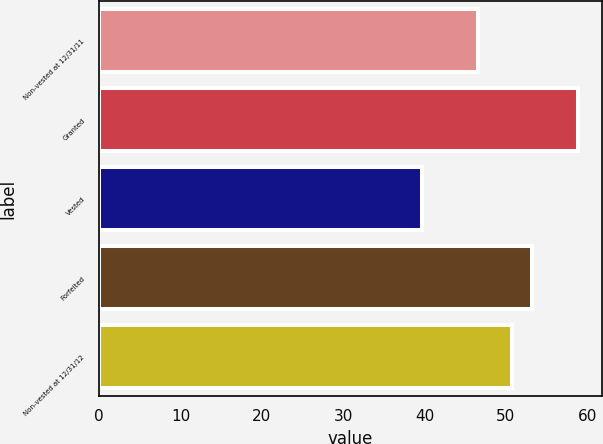<chart> <loc_0><loc_0><loc_500><loc_500><bar_chart><fcel>Non-vested at 12/31/11<fcel>Granted<fcel>Vested<fcel>Forfeited<fcel>Non-vested at 12/31/12<nl><fcel>46.6<fcel>58.84<fcel>39.67<fcel>53.18<fcel>50.78<nl></chart> 